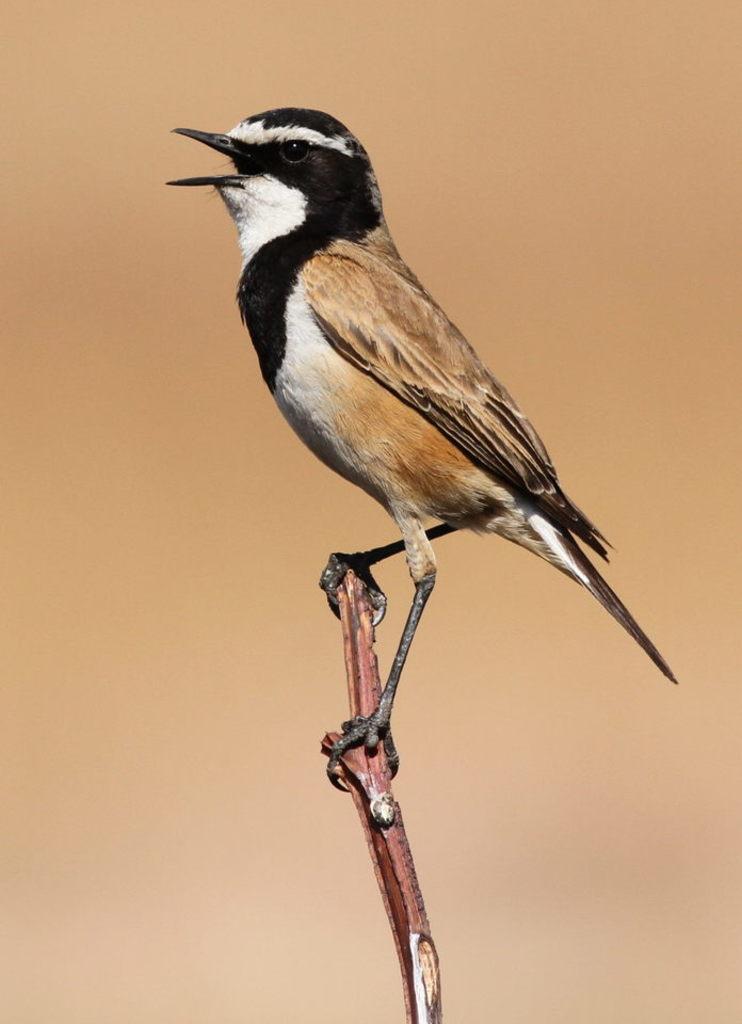In one or two sentences, can you explain what this image depicts? In this image, we can see a bird is on the stem. Background there is a blur view. 